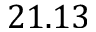<formula> <loc_0><loc_0><loc_500><loc_500>2 1 . 1 3</formula> 